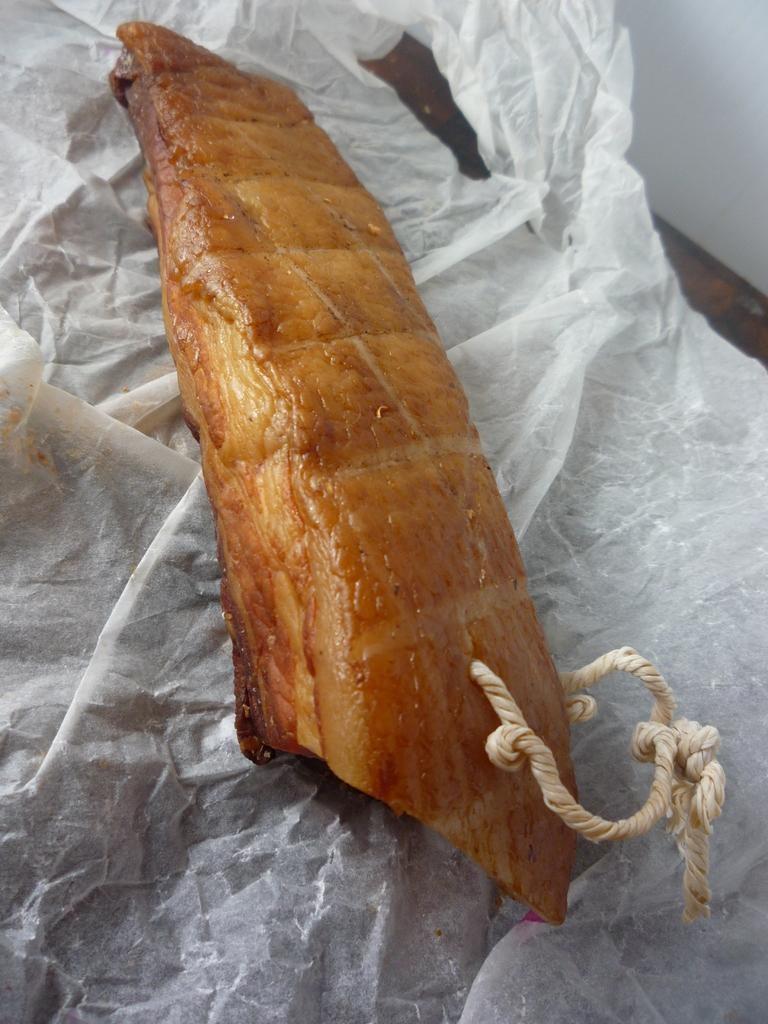What is the main subject of the image? There is a food item in the image. How is the food item being supported or held? The food item is on a tissue. What can be seen in the background of the image? There is a table in the background of the image. What type of legal advice is the food item providing in the image? The food item is not a lawyer and cannot provide legal advice. There is no lawyer or legal advice present in the image. 